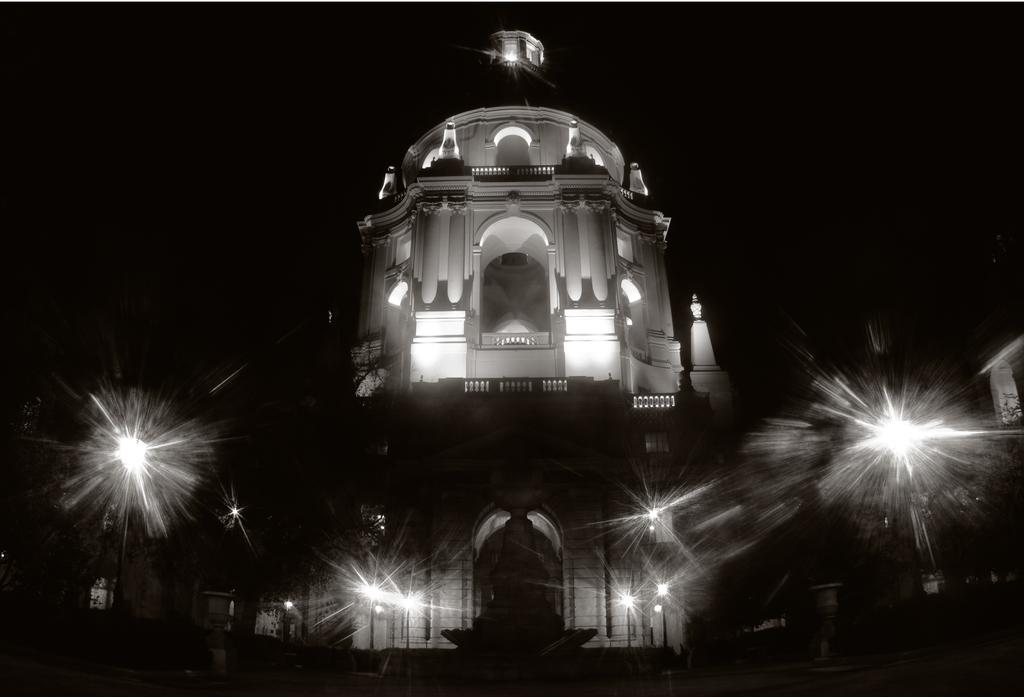What type of structure is visible in the image? There is a building in the image. What can be seen illuminating the scene in the image? There are lights in the image. What other objects can be seen in the image besides the building and lights? There are other objects in the image. What type of knife can be seen floating in the bubble in the image? There is no knife or bubble present in the image. 